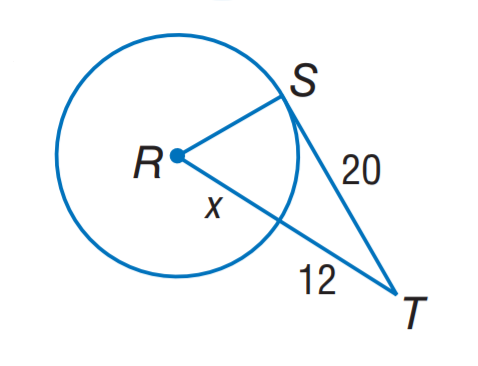Answer the mathemtical geometry problem and directly provide the correct option letter.
Question: The segment is tangent to the circle. Find x. Round to the nearest tenth.
Choices: A: 8.0 B: 10.7 C: 13.5 D: 22.7 B 